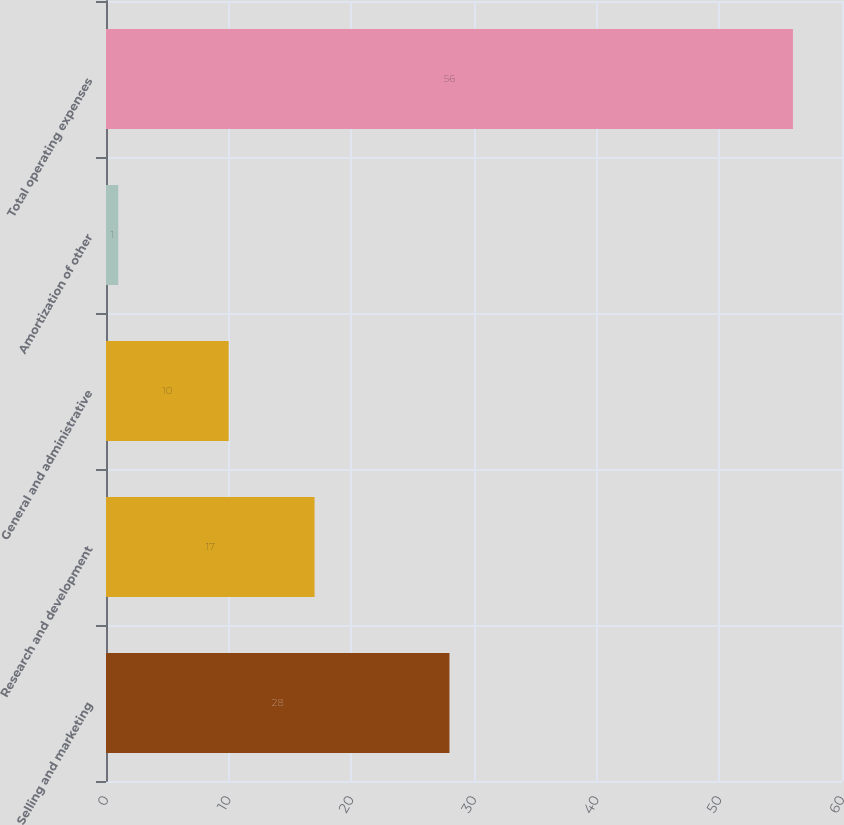Convert chart. <chart><loc_0><loc_0><loc_500><loc_500><bar_chart><fcel>Selling and marketing<fcel>Research and development<fcel>General and administrative<fcel>Amortization of other<fcel>Total operating expenses<nl><fcel>28<fcel>17<fcel>10<fcel>1<fcel>56<nl></chart> 